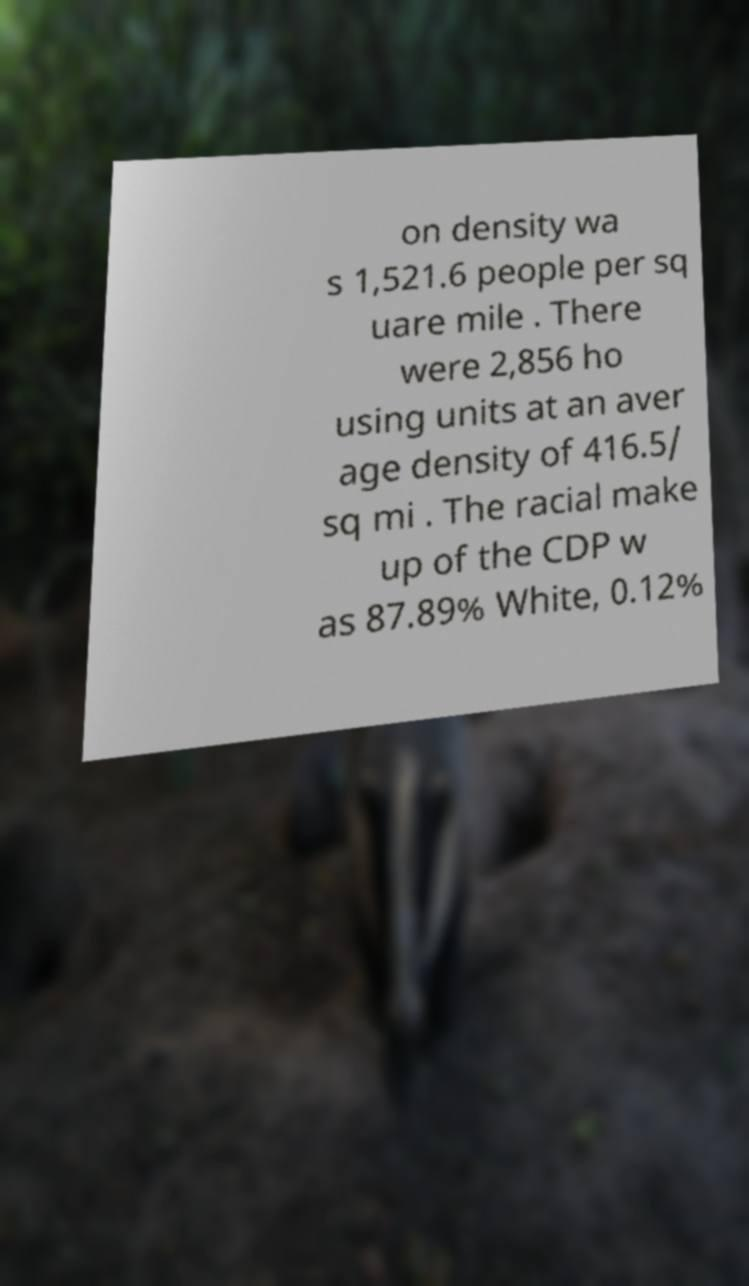There's text embedded in this image that I need extracted. Can you transcribe it verbatim? on density wa s 1,521.6 people per sq uare mile . There were 2,856 ho using units at an aver age density of 416.5/ sq mi . The racial make up of the CDP w as 87.89% White, 0.12% 